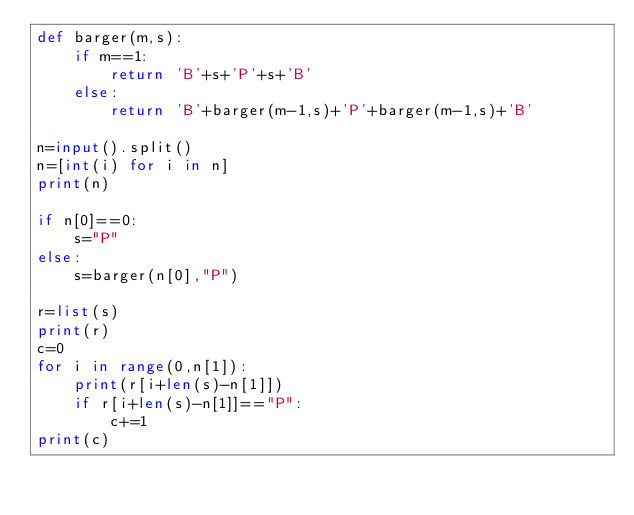Convert code to text. <code><loc_0><loc_0><loc_500><loc_500><_Python_>def barger(m,s):
    if m==1:
        return 'B'+s+'P'+s+'B'
    else:
        return 'B'+barger(m-1,s)+'P'+barger(m-1,s)+'B'

n=input().split()
n=[int(i) for i in n]
print(n)

if n[0]==0:
    s="P"
else:
    s=barger(n[0],"P")

r=list(s)
print(r)
c=0
for i in range(0,n[1]):
    print(r[i+len(s)-n[1]])
    if r[i+len(s)-n[1]]=="P":
        c+=1
print(c)</code> 